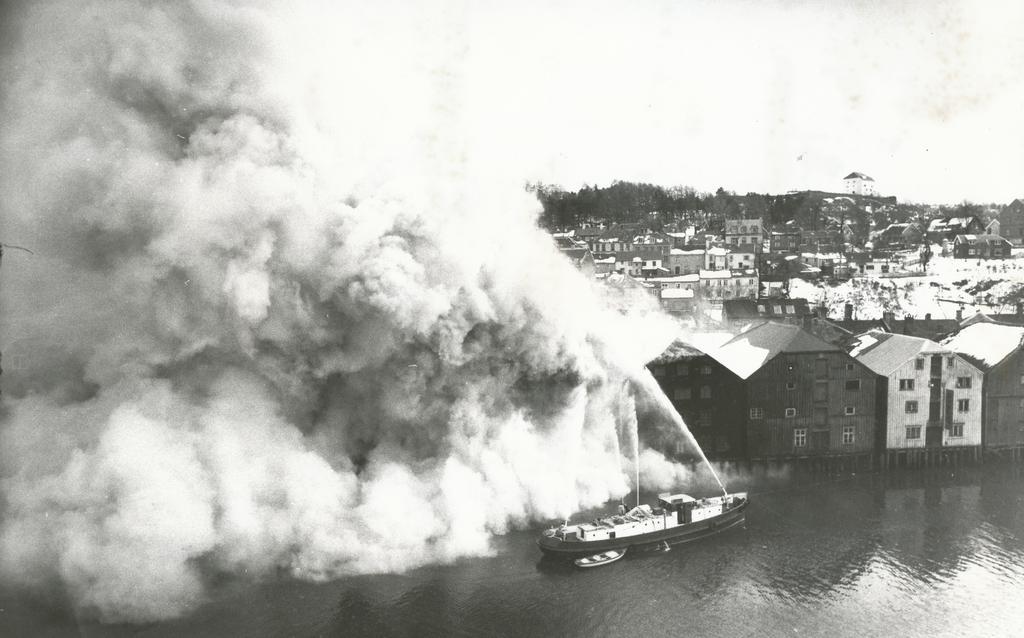Can you describe this image briefly? In this picture there are buildings and trees. In the foreground there is a ship and there is a boat on the water. On the left side of the image there is smoke. At the top there is sky. At the bottom there is water. 